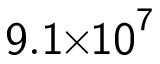<formula> <loc_0><loc_0><loc_500><loc_500>9 . 1 \, \times \, 1 0 ^ { 7 }</formula> 